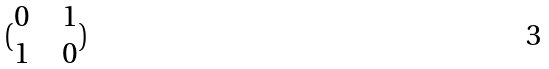Convert formula to latex. <formula><loc_0><loc_0><loc_500><loc_500>( \begin{matrix} 0 & & 1 \\ 1 & & 0 \end{matrix} )</formula> 